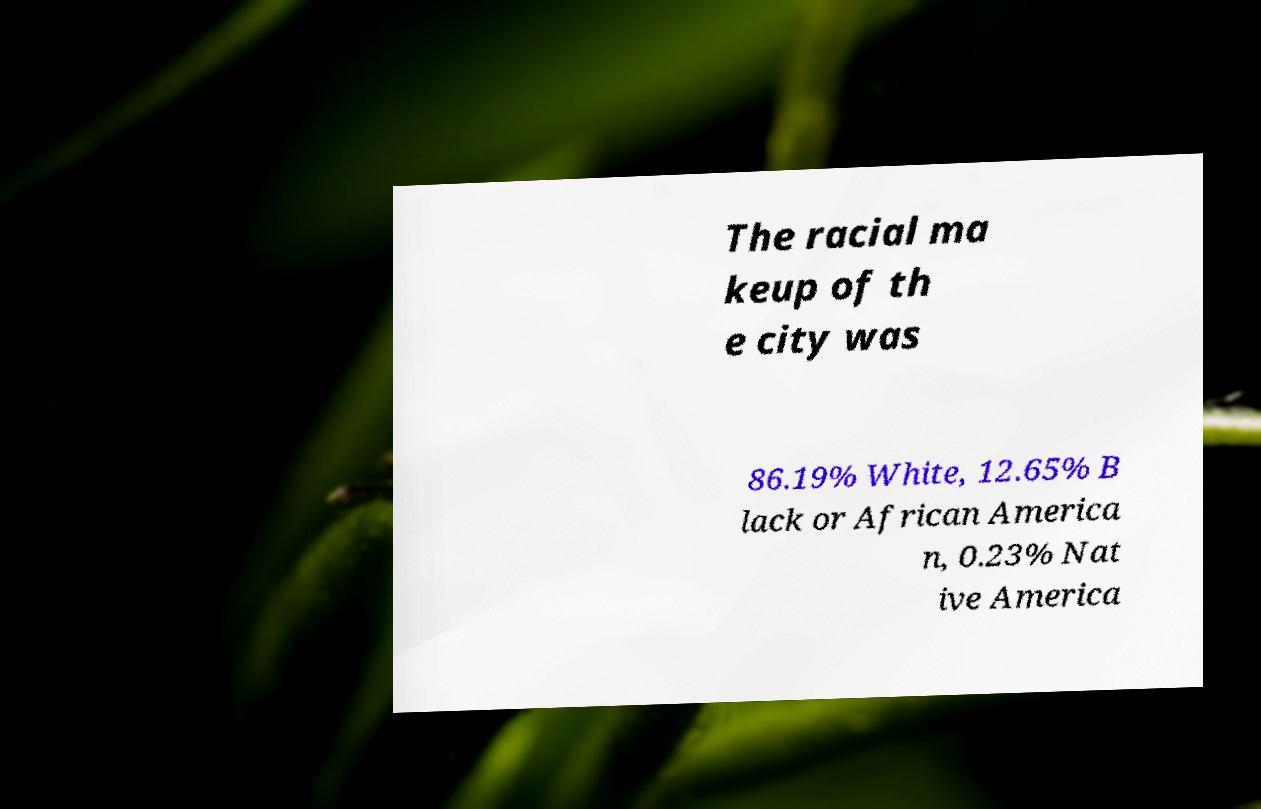Could you assist in decoding the text presented in this image and type it out clearly? The racial ma keup of th e city was 86.19% White, 12.65% B lack or African America n, 0.23% Nat ive America 